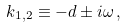Convert formula to latex. <formula><loc_0><loc_0><loc_500><loc_500>k _ { 1 , 2 } \equiv - d \pm i \omega \, ,</formula> 